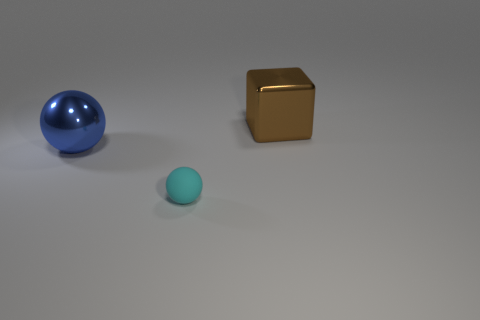Are the objects arranged in any particular pattern? The objects are laid out in an asymmetrical fashion with no discernible pattern. The placement seems random, with varying distances between each item, providing an interesting composition of shapes and colors. 